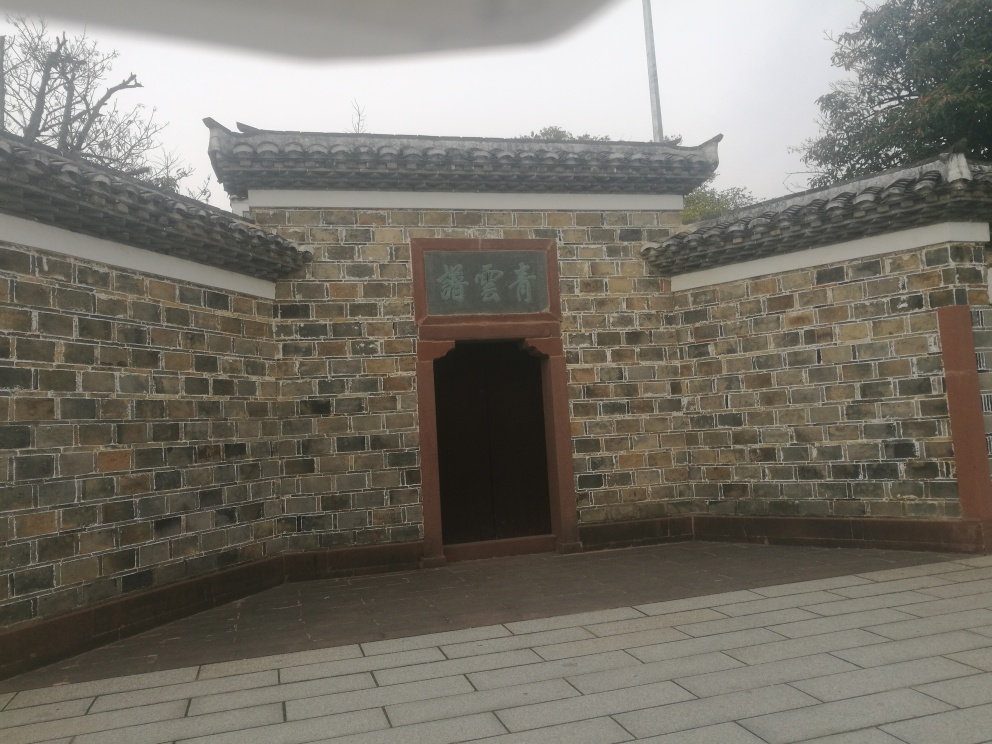Can you tell me more about the architectural style of the building? This building appears to exhibit characteristics of traditional East Asian architecture, noticeable from the curved roof edges, the use of gray tiles, and the distinct brickwork. The style may suggest that this structure draws inspiration from historic Chinese or Korean design elements, commonly seen in temples, historic dwellings, or government buildings. 